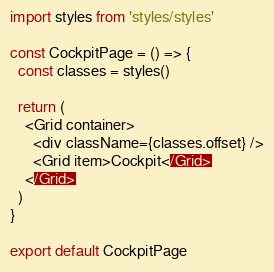<code> <loc_0><loc_0><loc_500><loc_500><_JavaScript_>import styles from 'styles/styles'

const CockpitPage = () => {
  const classes = styles()

  return (
    <Grid container>
      <div className={classes.offset} />
      <Grid item>Cockpit</Grid>
    </Grid>
  )
}

export default CockpitPage
</code> 